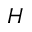<formula> <loc_0><loc_0><loc_500><loc_500>H</formula> 